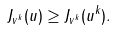Convert formula to latex. <formula><loc_0><loc_0><loc_500><loc_500>J _ { v ^ { k } } ( u ) \geq J _ { v ^ { k } } ( u ^ { k } ) .</formula> 